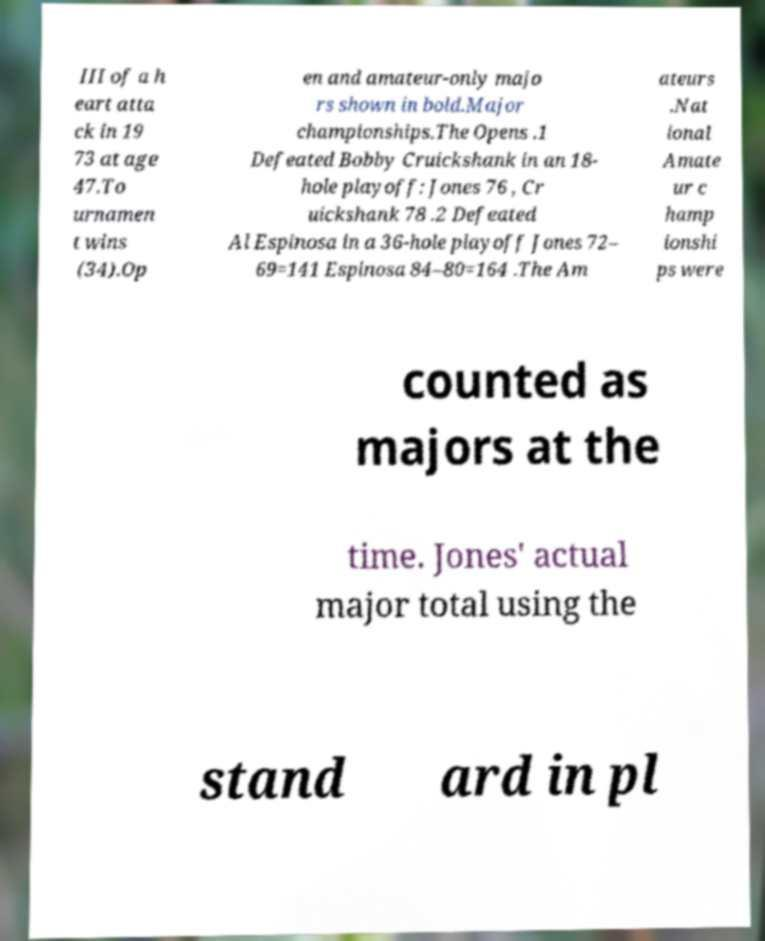I need the written content from this picture converted into text. Can you do that? III of a h eart atta ck in 19 73 at age 47.To urnamen t wins (34).Op en and amateur-only majo rs shown in bold.Major championships.The Opens .1 Defeated Bobby Cruickshank in an 18- hole playoff: Jones 76 , Cr uickshank 78 .2 Defeated Al Espinosa in a 36-hole playoff Jones 72– 69=141 Espinosa 84–80=164 .The Am ateurs .Nat ional Amate ur c hamp ionshi ps were counted as majors at the time. Jones' actual major total using the stand ard in pl 